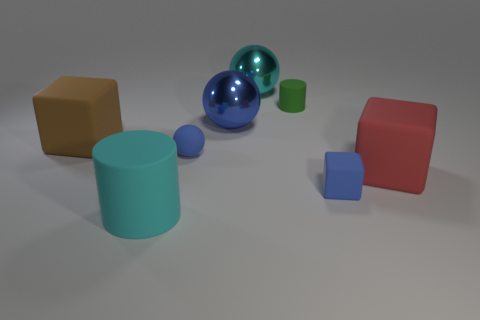Subtract all blue matte spheres. How many spheres are left? 2 Add 1 green rubber cylinders. How many objects exist? 9 Subtract 1 balls. How many balls are left? 2 Subtract all cyan cylinders. How many blue spheres are left? 2 Subtract all cylinders. How many objects are left? 6 Subtract 0 blue cylinders. How many objects are left? 8 Subtract all blue cylinders. Subtract all green cubes. How many cylinders are left? 2 Subtract all red matte things. Subtract all large green matte cylinders. How many objects are left? 7 Add 7 tiny green rubber things. How many tiny green rubber things are left? 8 Add 1 blue objects. How many blue objects exist? 4 